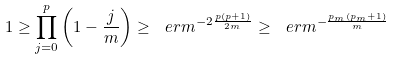<formula> <loc_0><loc_0><loc_500><loc_500>1 \geq \prod _ { j = 0 } ^ { p } \left ( 1 - \frac { j } { m } \right ) \geq \ e r m ^ { - 2 \frac { p ( p + 1 ) } { 2 m } } \geq \ e r m ^ { - \frac { p _ { m } ( p _ { m } + 1 ) } { m } } \</formula> 